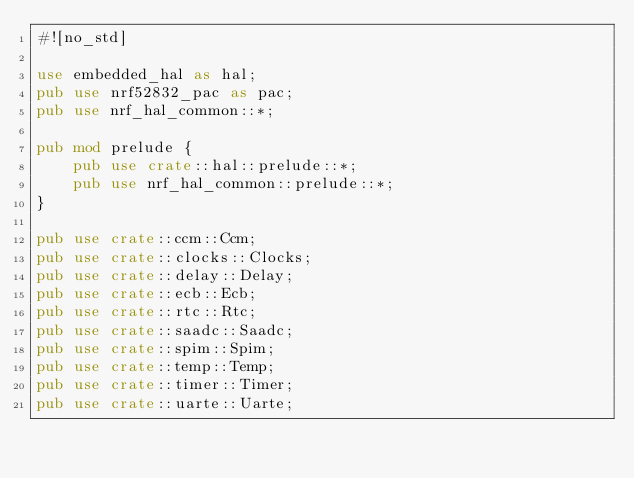<code> <loc_0><loc_0><loc_500><loc_500><_Rust_>#![no_std]

use embedded_hal as hal;
pub use nrf52832_pac as pac;
pub use nrf_hal_common::*;

pub mod prelude {
    pub use crate::hal::prelude::*;
    pub use nrf_hal_common::prelude::*;
}

pub use crate::ccm::Ccm;
pub use crate::clocks::Clocks;
pub use crate::delay::Delay;
pub use crate::ecb::Ecb;
pub use crate::rtc::Rtc;
pub use crate::saadc::Saadc;
pub use crate::spim::Spim;
pub use crate::temp::Temp;
pub use crate::timer::Timer;
pub use crate::uarte::Uarte;
</code> 